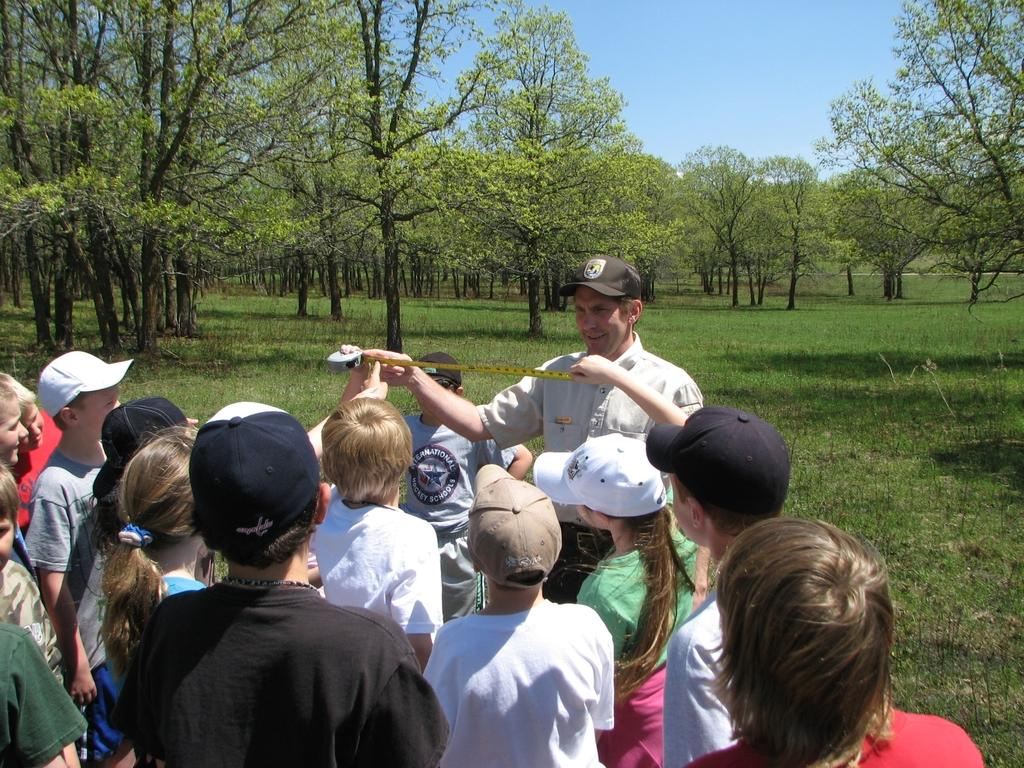What are the people in the image doing? The people in the image are standing, and some of them are holding measuring tapes. What type of environment is depicted in the image? The image shows a grassy area with trees. What can be seen in the background of the image? The sky is visible in the background of the image. What type of toys are scattered around the scarecrow in the image? There is no scarecrow or toys present in the image. What is the rate of growth for the plants in the image? The image does not provide information about the rate of growth for any plants. 